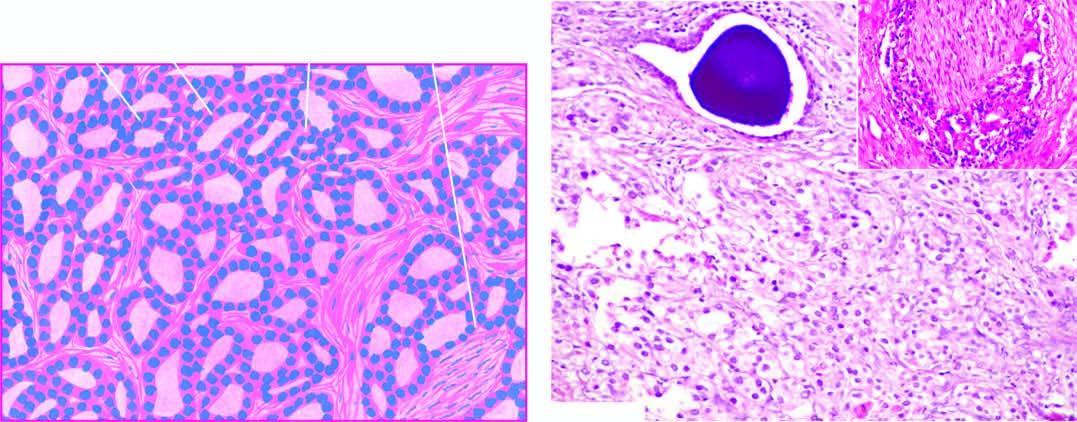what shows microacini of small malignant cells infiltrating the prostatic stroma?
Answer the question using a single word or phrase. The field stroma 